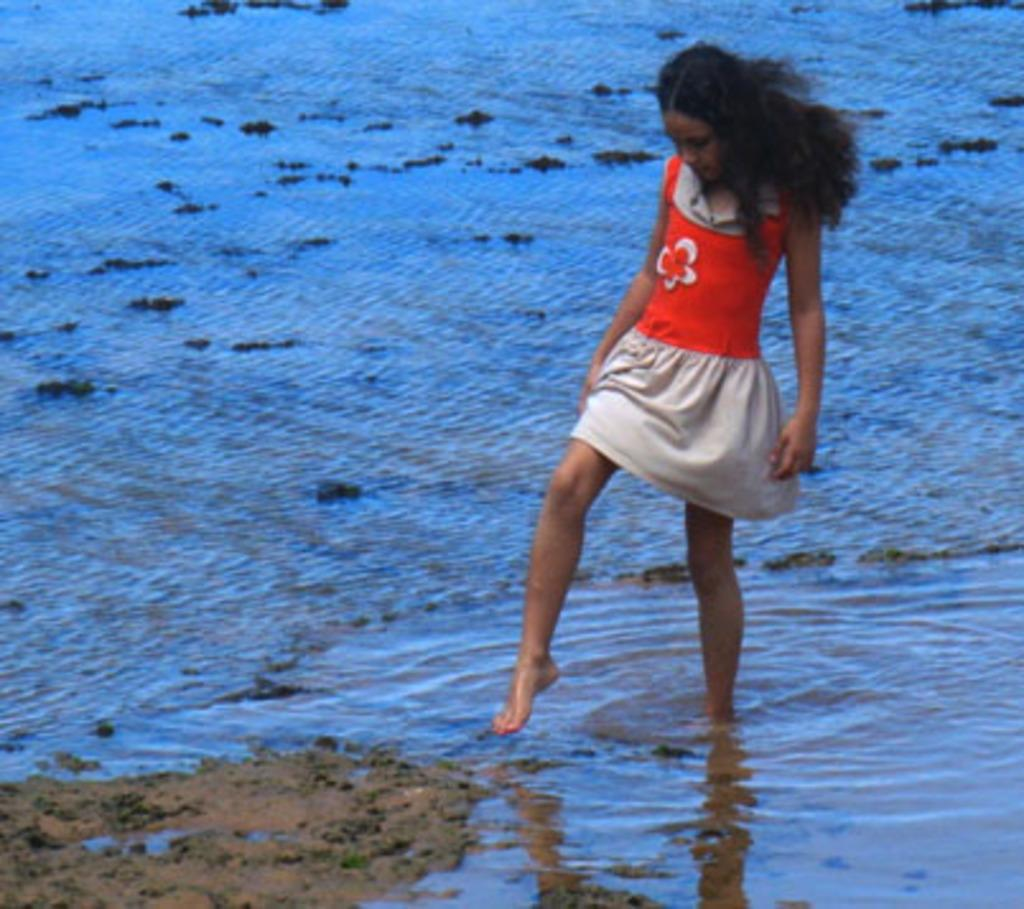Who is the main subject in the image? There is a girl in the image. What is the girl wearing? The girl is wearing a red and grey color dress. Where is the girl standing in the image? The girl is standing on the water. What can be seen in the bottom left corner of the image? There is land visible in the bottom left corner of the image. Can you see the girl's uncle in the image? There is no uncle present in the image; it only features the girl. Where is the nest of the bird in the image? There is no bird or nest present in the image; it only features the girl standing on the water. 